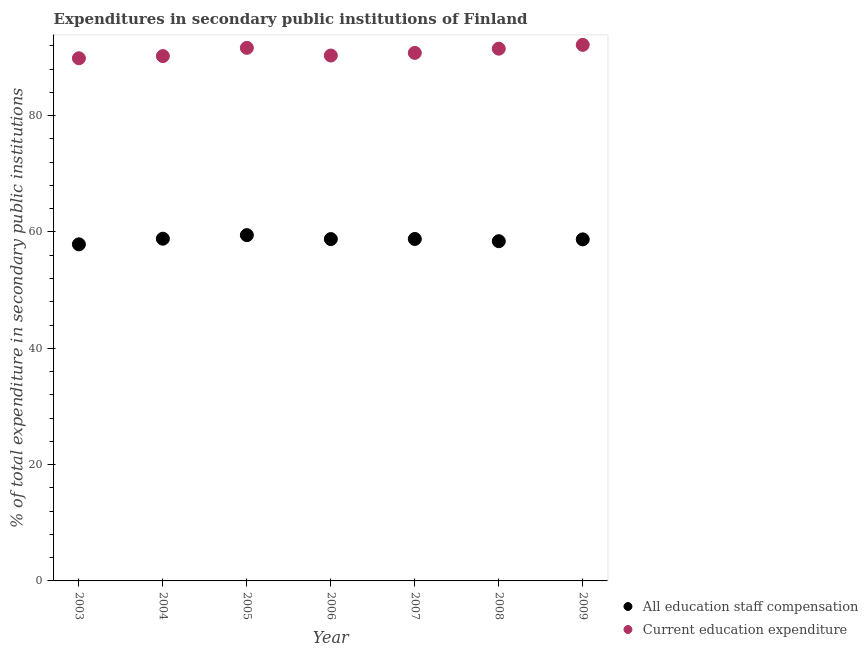What is the expenditure in education in 2009?
Ensure brevity in your answer.  92.17. Across all years, what is the maximum expenditure in staff compensation?
Provide a short and direct response. 59.45. Across all years, what is the minimum expenditure in education?
Your answer should be very brief. 89.87. In which year was the expenditure in education maximum?
Ensure brevity in your answer.  2009. What is the total expenditure in education in the graph?
Offer a very short reply. 636.58. What is the difference between the expenditure in staff compensation in 2006 and that in 2008?
Your answer should be very brief. 0.36. What is the difference between the expenditure in staff compensation in 2007 and the expenditure in education in 2004?
Your response must be concise. -31.45. What is the average expenditure in staff compensation per year?
Your answer should be compact. 58.7. In the year 2006, what is the difference between the expenditure in staff compensation and expenditure in education?
Provide a short and direct response. -31.56. In how many years, is the expenditure in education greater than 40 %?
Your answer should be compact. 7. What is the ratio of the expenditure in education in 2003 to that in 2005?
Make the answer very short. 0.98. Is the difference between the expenditure in staff compensation in 2006 and 2008 greater than the difference between the expenditure in education in 2006 and 2008?
Offer a terse response. Yes. What is the difference between the highest and the second highest expenditure in education?
Your response must be concise. 0.52. What is the difference between the highest and the lowest expenditure in education?
Keep it short and to the point. 2.31. Does the expenditure in staff compensation monotonically increase over the years?
Offer a terse response. No. Is the expenditure in staff compensation strictly greater than the expenditure in education over the years?
Provide a succinct answer. No. Is the expenditure in education strictly less than the expenditure in staff compensation over the years?
Provide a short and direct response. No. Does the graph contain any zero values?
Give a very brief answer. No. Does the graph contain grids?
Offer a terse response. No. How many legend labels are there?
Make the answer very short. 2. How are the legend labels stacked?
Provide a succinct answer. Vertical. What is the title of the graph?
Ensure brevity in your answer.  Expenditures in secondary public institutions of Finland. Does "Crop" appear as one of the legend labels in the graph?
Offer a very short reply. No. What is the label or title of the Y-axis?
Your answer should be compact. % of total expenditure in secondary public institutions. What is the % of total expenditure in secondary public institutions in All education staff compensation in 2003?
Your answer should be compact. 57.87. What is the % of total expenditure in secondary public institutions in Current education expenditure in 2003?
Your answer should be very brief. 89.87. What is the % of total expenditure in secondary public institutions of All education staff compensation in 2004?
Ensure brevity in your answer.  58.84. What is the % of total expenditure in secondary public institutions in Current education expenditure in 2004?
Offer a very short reply. 90.24. What is the % of total expenditure in secondary public institutions of All education staff compensation in 2005?
Offer a terse response. 59.45. What is the % of total expenditure in secondary public institutions of Current education expenditure in 2005?
Provide a succinct answer. 91.66. What is the % of total expenditure in secondary public institutions of All education staff compensation in 2006?
Your answer should be very brief. 58.78. What is the % of total expenditure in secondary public institutions of Current education expenditure in 2006?
Provide a succinct answer. 90.34. What is the % of total expenditure in secondary public institutions of All education staff compensation in 2007?
Ensure brevity in your answer.  58.8. What is the % of total expenditure in secondary public institutions in Current education expenditure in 2007?
Give a very brief answer. 90.79. What is the % of total expenditure in secondary public institutions of All education staff compensation in 2008?
Your response must be concise. 58.42. What is the % of total expenditure in secondary public institutions of Current education expenditure in 2008?
Make the answer very short. 91.51. What is the % of total expenditure in secondary public institutions of All education staff compensation in 2009?
Make the answer very short. 58.73. What is the % of total expenditure in secondary public institutions of Current education expenditure in 2009?
Keep it short and to the point. 92.17. Across all years, what is the maximum % of total expenditure in secondary public institutions of All education staff compensation?
Offer a terse response. 59.45. Across all years, what is the maximum % of total expenditure in secondary public institutions of Current education expenditure?
Your answer should be compact. 92.17. Across all years, what is the minimum % of total expenditure in secondary public institutions of All education staff compensation?
Your answer should be compact. 57.87. Across all years, what is the minimum % of total expenditure in secondary public institutions in Current education expenditure?
Provide a succinct answer. 89.87. What is the total % of total expenditure in secondary public institutions in All education staff compensation in the graph?
Your answer should be very brief. 410.89. What is the total % of total expenditure in secondary public institutions in Current education expenditure in the graph?
Provide a succinct answer. 636.58. What is the difference between the % of total expenditure in secondary public institutions in All education staff compensation in 2003 and that in 2004?
Provide a succinct answer. -0.97. What is the difference between the % of total expenditure in secondary public institutions of Current education expenditure in 2003 and that in 2004?
Make the answer very short. -0.38. What is the difference between the % of total expenditure in secondary public institutions of All education staff compensation in 2003 and that in 2005?
Your answer should be compact. -1.58. What is the difference between the % of total expenditure in secondary public institutions of Current education expenditure in 2003 and that in 2005?
Your answer should be very brief. -1.79. What is the difference between the % of total expenditure in secondary public institutions in All education staff compensation in 2003 and that in 2006?
Keep it short and to the point. -0.9. What is the difference between the % of total expenditure in secondary public institutions in Current education expenditure in 2003 and that in 2006?
Offer a terse response. -0.47. What is the difference between the % of total expenditure in secondary public institutions in All education staff compensation in 2003 and that in 2007?
Give a very brief answer. -0.92. What is the difference between the % of total expenditure in secondary public institutions in Current education expenditure in 2003 and that in 2007?
Your answer should be very brief. -0.92. What is the difference between the % of total expenditure in secondary public institutions in All education staff compensation in 2003 and that in 2008?
Your answer should be compact. -0.54. What is the difference between the % of total expenditure in secondary public institutions of Current education expenditure in 2003 and that in 2008?
Keep it short and to the point. -1.65. What is the difference between the % of total expenditure in secondary public institutions of All education staff compensation in 2003 and that in 2009?
Give a very brief answer. -0.85. What is the difference between the % of total expenditure in secondary public institutions in Current education expenditure in 2003 and that in 2009?
Your answer should be very brief. -2.31. What is the difference between the % of total expenditure in secondary public institutions in All education staff compensation in 2004 and that in 2005?
Give a very brief answer. -0.61. What is the difference between the % of total expenditure in secondary public institutions of Current education expenditure in 2004 and that in 2005?
Offer a very short reply. -1.41. What is the difference between the % of total expenditure in secondary public institutions of All education staff compensation in 2004 and that in 2006?
Your answer should be compact. 0.07. What is the difference between the % of total expenditure in secondary public institutions of Current education expenditure in 2004 and that in 2006?
Keep it short and to the point. -0.09. What is the difference between the % of total expenditure in secondary public institutions of All education staff compensation in 2004 and that in 2007?
Your answer should be very brief. 0.05. What is the difference between the % of total expenditure in secondary public institutions of Current education expenditure in 2004 and that in 2007?
Make the answer very short. -0.55. What is the difference between the % of total expenditure in secondary public institutions in All education staff compensation in 2004 and that in 2008?
Your response must be concise. 0.43. What is the difference between the % of total expenditure in secondary public institutions in Current education expenditure in 2004 and that in 2008?
Your answer should be compact. -1.27. What is the difference between the % of total expenditure in secondary public institutions of All education staff compensation in 2004 and that in 2009?
Offer a terse response. 0.12. What is the difference between the % of total expenditure in secondary public institutions in Current education expenditure in 2004 and that in 2009?
Your response must be concise. -1.93. What is the difference between the % of total expenditure in secondary public institutions in All education staff compensation in 2005 and that in 2006?
Provide a succinct answer. 0.68. What is the difference between the % of total expenditure in secondary public institutions in Current education expenditure in 2005 and that in 2006?
Your answer should be very brief. 1.32. What is the difference between the % of total expenditure in secondary public institutions of All education staff compensation in 2005 and that in 2007?
Your answer should be compact. 0.66. What is the difference between the % of total expenditure in secondary public institutions in Current education expenditure in 2005 and that in 2007?
Your response must be concise. 0.87. What is the difference between the % of total expenditure in secondary public institutions in Current education expenditure in 2005 and that in 2008?
Offer a terse response. 0.14. What is the difference between the % of total expenditure in secondary public institutions of All education staff compensation in 2005 and that in 2009?
Provide a succinct answer. 0.73. What is the difference between the % of total expenditure in secondary public institutions in Current education expenditure in 2005 and that in 2009?
Provide a short and direct response. -0.52. What is the difference between the % of total expenditure in secondary public institutions of All education staff compensation in 2006 and that in 2007?
Your answer should be compact. -0.02. What is the difference between the % of total expenditure in secondary public institutions in Current education expenditure in 2006 and that in 2007?
Your response must be concise. -0.45. What is the difference between the % of total expenditure in secondary public institutions in All education staff compensation in 2006 and that in 2008?
Provide a short and direct response. 0.36. What is the difference between the % of total expenditure in secondary public institutions of Current education expenditure in 2006 and that in 2008?
Offer a very short reply. -1.18. What is the difference between the % of total expenditure in secondary public institutions of All education staff compensation in 2006 and that in 2009?
Ensure brevity in your answer.  0.05. What is the difference between the % of total expenditure in secondary public institutions in Current education expenditure in 2006 and that in 2009?
Ensure brevity in your answer.  -1.84. What is the difference between the % of total expenditure in secondary public institutions in All education staff compensation in 2007 and that in 2008?
Give a very brief answer. 0.38. What is the difference between the % of total expenditure in secondary public institutions of Current education expenditure in 2007 and that in 2008?
Give a very brief answer. -0.72. What is the difference between the % of total expenditure in secondary public institutions in All education staff compensation in 2007 and that in 2009?
Ensure brevity in your answer.  0.07. What is the difference between the % of total expenditure in secondary public institutions of Current education expenditure in 2007 and that in 2009?
Your response must be concise. -1.38. What is the difference between the % of total expenditure in secondary public institutions of All education staff compensation in 2008 and that in 2009?
Your response must be concise. -0.31. What is the difference between the % of total expenditure in secondary public institutions in Current education expenditure in 2008 and that in 2009?
Make the answer very short. -0.66. What is the difference between the % of total expenditure in secondary public institutions of All education staff compensation in 2003 and the % of total expenditure in secondary public institutions of Current education expenditure in 2004?
Provide a short and direct response. -32.37. What is the difference between the % of total expenditure in secondary public institutions of All education staff compensation in 2003 and the % of total expenditure in secondary public institutions of Current education expenditure in 2005?
Provide a short and direct response. -33.78. What is the difference between the % of total expenditure in secondary public institutions in All education staff compensation in 2003 and the % of total expenditure in secondary public institutions in Current education expenditure in 2006?
Give a very brief answer. -32.46. What is the difference between the % of total expenditure in secondary public institutions in All education staff compensation in 2003 and the % of total expenditure in secondary public institutions in Current education expenditure in 2007?
Provide a short and direct response. -32.92. What is the difference between the % of total expenditure in secondary public institutions in All education staff compensation in 2003 and the % of total expenditure in secondary public institutions in Current education expenditure in 2008?
Provide a short and direct response. -33.64. What is the difference between the % of total expenditure in secondary public institutions of All education staff compensation in 2003 and the % of total expenditure in secondary public institutions of Current education expenditure in 2009?
Keep it short and to the point. -34.3. What is the difference between the % of total expenditure in secondary public institutions in All education staff compensation in 2004 and the % of total expenditure in secondary public institutions in Current education expenditure in 2005?
Make the answer very short. -32.81. What is the difference between the % of total expenditure in secondary public institutions in All education staff compensation in 2004 and the % of total expenditure in secondary public institutions in Current education expenditure in 2006?
Keep it short and to the point. -31.49. What is the difference between the % of total expenditure in secondary public institutions in All education staff compensation in 2004 and the % of total expenditure in secondary public institutions in Current education expenditure in 2007?
Give a very brief answer. -31.95. What is the difference between the % of total expenditure in secondary public institutions of All education staff compensation in 2004 and the % of total expenditure in secondary public institutions of Current education expenditure in 2008?
Ensure brevity in your answer.  -32.67. What is the difference between the % of total expenditure in secondary public institutions of All education staff compensation in 2004 and the % of total expenditure in secondary public institutions of Current education expenditure in 2009?
Offer a terse response. -33.33. What is the difference between the % of total expenditure in secondary public institutions of All education staff compensation in 2005 and the % of total expenditure in secondary public institutions of Current education expenditure in 2006?
Offer a very short reply. -30.88. What is the difference between the % of total expenditure in secondary public institutions in All education staff compensation in 2005 and the % of total expenditure in secondary public institutions in Current education expenditure in 2007?
Offer a terse response. -31.34. What is the difference between the % of total expenditure in secondary public institutions of All education staff compensation in 2005 and the % of total expenditure in secondary public institutions of Current education expenditure in 2008?
Your answer should be compact. -32.06. What is the difference between the % of total expenditure in secondary public institutions of All education staff compensation in 2005 and the % of total expenditure in secondary public institutions of Current education expenditure in 2009?
Your response must be concise. -32.72. What is the difference between the % of total expenditure in secondary public institutions in All education staff compensation in 2006 and the % of total expenditure in secondary public institutions in Current education expenditure in 2007?
Make the answer very short. -32.01. What is the difference between the % of total expenditure in secondary public institutions in All education staff compensation in 2006 and the % of total expenditure in secondary public institutions in Current education expenditure in 2008?
Ensure brevity in your answer.  -32.74. What is the difference between the % of total expenditure in secondary public institutions of All education staff compensation in 2006 and the % of total expenditure in secondary public institutions of Current education expenditure in 2009?
Provide a short and direct response. -33.4. What is the difference between the % of total expenditure in secondary public institutions of All education staff compensation in 2007 and the % of total expenditure in secondary public institutions of Current education expenditure in 2008?
Offer a terse response. -32.72. What is the difference between the % of total expenditure in secondary public institutions in All education staff compensation in 2007 and the % of total expenditure in secondary public institutions in Current education expenditure in 2009?
Your answer should be very brief. -33.38. What is the difference between the % of total expenditure in secondary public institutions of All education staff compensation in 2008 and the % of total expenditure in secondary public institutions of Current education expenditure in 2009?
Provide a short and direct response. -33.76. What is the average % of total expenditure in secondary public institutions of All education staff compensation per year?
Your response must be concise. 58.7. What is the average % of total expenditure in secondary public institutions of Current education expenditure per year?
Your answer should be very brief. 90.94. In the year 2003, what is the difference between the % of total expenditure in secondary public institutions of All education staff compensation and % of total expenditure in secondary public institutions of Current education expenditure?
Your answer should be compact. -31.99. In the year 2004, what is the difference between the % of total expenditure in secondary public institutions of All education staff compensation and % of total expenditure in secondary public institutions of Current education expenditure?
Make the answer very short. -31.4. In the year 2005, what is the difference between the % of total expenditure in secondary public institutions of All education staff compensation and % of total expenditure in secondary public institutions of Current education expenditure?
Offer a terse response. -32.2. In the year 2006, what is the difference between the % of total expenditure in secondary public institutions in All education staff compensation and % of total expenditure in secondary public institutions in Current education expenditure?
Give a very brief answer. -31.56. In the year 2007, what is the difference between the % of total expenditure in secondary public institutions in All education staff compensation and % of total expenditure in secondary public institutions in Current education expenditure?
Your answer should be very brief. -31.99. In the year 2008, what is the difference between the % of total expenditure in secondary public institutions of All education staff compensation and % of total expenditure in secondary public institutions of Current education expenditure?
Make the answer very short. -33.1. In the year 2009, what is the difference between the % of total expenditure in secondary public institutions in All education staff compensation and % of total expenditure in secondary public institutions in Current education expenditure?
Offer a terse response. -33.45. What is the ratio of the % of total expenditure in secondary public institutions of All education staff compensation in 2003 to that in 2004?
Provide a short and direct response. 0.98. What is the ratio of the % of total expenditure in secondary public institutions of All education staff compensation in 2003 to that in 2005?
Make the answer very short. 0.97. What is the ratio of the % of total expenditure in secondary public institutions of Current education expenditure in 2003 to that in 2005?
Make the answer very short. 0.98. What is the ratio of the % of total expenditure in secondary public institutions in All education staff compensation in 2003 to that in 2006?
Your answer should be very brief. 0.98. What is the ratio of the % of total expenditure in secondary public institutions in Current education expenditure in 2003 to that in 2006?
Offer a terse response. 0.99. What is the ratio of the % of total expenditure in secondary public institutions in All education staff compensation in 2003 to that in 2007?
Your answer should be compact. 0.98. What is the ratio of the % of total expenditure in secondary public institutions in Current education expenditure in 2003 to that in 2008?
Offer a very short reply. 0.98. What is the ratio of the % of total expenditure in secondary public institutions in All education staff compensation in 2003 to that in 2009?
Make the answer very short. 0.99. What is the ratio of the % of total expenditure in secondary public institutions in Current education expenditure in 2003 to that in 2009?
Offer a very short reply. 0.97. What is the ratio of the % of total expenditure in secondary public institutions in Current education expenditure in 2004 to that in 2005?
Offer a terse response. 0.98. What is the ratio of the % of total expenditure in secondary public institutions in All education staff compensation in 2004 to that in 2006?
Keep it short and to the point. 1. What is the ratio of the % of total expenditure in secondary public institutions in All education staff compensation in 2004 to that in 2007?
Provide a succinct answer. 1. What is the ratio of the % of total expenditure in secondary public institutions in Current education expenditure in 2004 to that in 2007?
Give a very brief answer. 0.99. What is the ratio of the % of total expenditure in secondary public institutions in All education staff compensation in 2004 to that in 2008?
Your answer should be very brief. 1.01. What is the ratio of the % of total expenditure in secondary public institutions in Current education expenditure in 2004 to that in 2008?
Give a very brief answer. 0.99. What is the ratio of the % of total expenditure in secondary public institutions of Current education expenditure in 2004 to that in 2009?
Your response must be concise. 0.98. What is the ratio of the % of total expenditure in secondary public institutions in All education staff compensation in 2005 to that in 2006?
Give a very brief answer. 1.01. What is the ratio of the % of total expenditure in secondary public institutions in Current education expenditure in 2005 to that in 2006?
Provide a succinct answer. 1.01. What is the ratio of the % of total expenditure in secondary public institutions in All education staff compensation in 2005 to that in 2007?
Make the answer very short. 1.01. What is the ratio of the % of total expenditure in secondary public institutions in Current education expenditure in 2005 to that in 2007?
Make the answer very short. 1.01. What is the ratio of the % of total expenditure in secondary public institutions of All education staff compensation in 2005 to that in 2008?
Ensure brevity in your answer.  1.02. What is the ratio of the % of total expenditure in secondary public institutions of Current education expenditure in 2005 to that in 2008?
Make the answer very short. 1. What is the ratio of the % of total expenditure in secondary public institutions in All education staff compensation in 2005 to that in 2009?
Ensure brevity in your answer.  1.01. What is the ratio of the % of total expenditure in secondary public institutions of All education staff compensation in 2006 to that in 2008?
Offer a very short reply. 1.01. What is the ratio of the % of total expenditure in secondary public institutions of Current education expenditure in 2006 to that in 2008?
Make the answer very short. 0.99. What is the ratio of the % of total expenditure in secondary public institutions of All education staff compensation in 2006 to that in 2009?
Make the answer very short. 1. What is the ratio of the % of total expenditure in secondary public institutions of Current education expenditure in 2006 to that in 2009?
Ensure brevity in your answer.  0.98. What is the ratio of the % of total expenditure in secondary public institutions in All education staff compensation in 2007 to that in 2009?
Provide a succinct answer. 1. What is the ratio of the % of total expenditure in secondary public institutions of Current education expenditure in 2008 to that in 2009?
Make the answer very short. 0.99. What is the difference between the highest and the second highest % of total expenditure in secondary public institutions in All education staff compensation?
Your answer should be very brief. 0.61. What is the difference between the highest and the second highest % of total expenditure in secondary public institutions of Current education expenditure?
Your answer should be very brief. 0.52. What is the difference between the highest and the lowest % of total expenditure in secondary public institutions in All education staff compensation?
Offer a terse response. 1.58. What is the difference between the highest and the lowest % of total expenditure in secondary public institutions of Current education expenditure?
Offer a terse response. 2.31. 